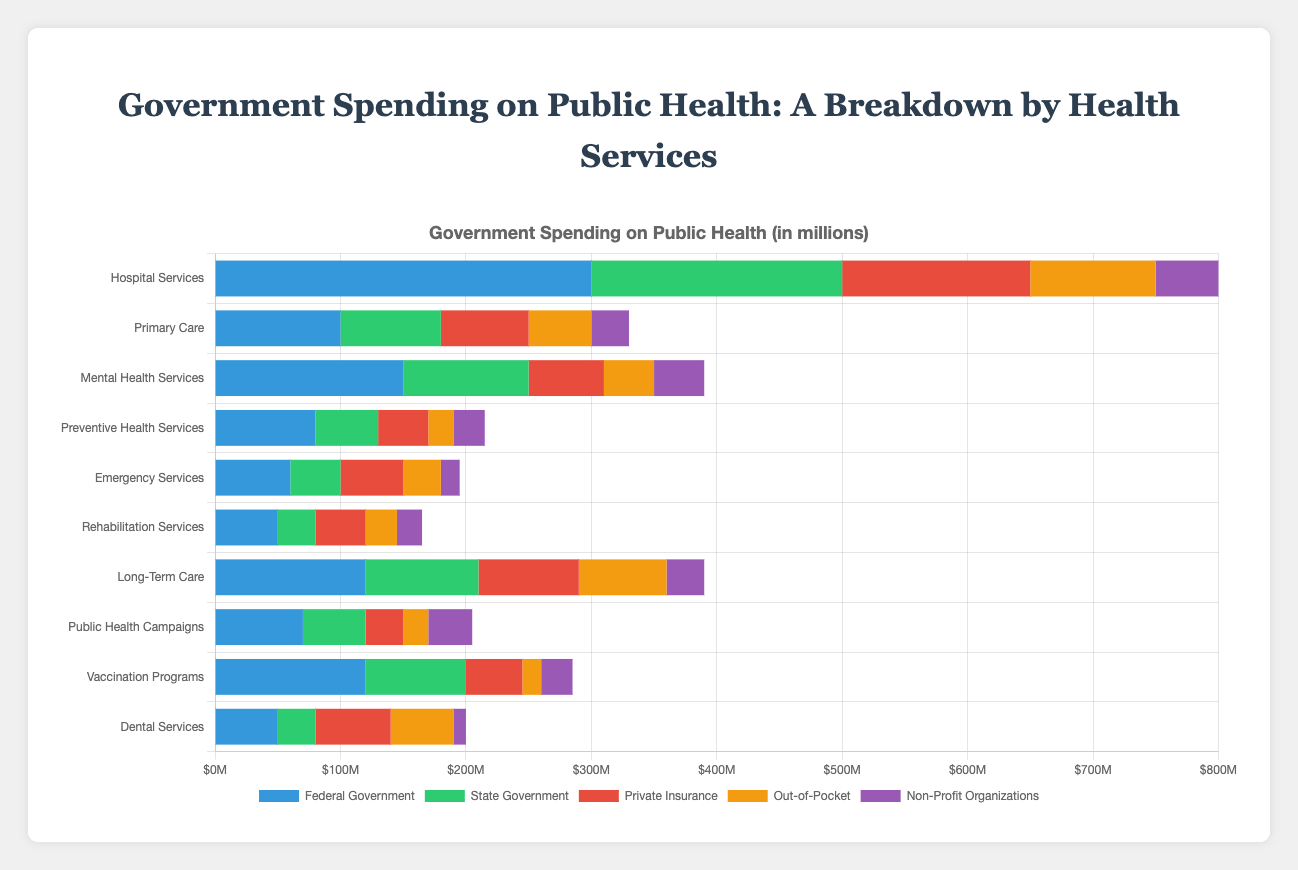Which health service has the highest federal government spending? By examining the horizontal stacked bar chart, the segment for "Federal Government" is the longest for "Hospital Services", indicating the highest federal government spending.
Answer: Hospital Services How much total spending (all sources combined) is there for mental health services? Sum the contributions from all five funding sources for "Mental Health Services": 150,000,000 (Federal) + 100,000,000 (State) + 60,000,000 (Private Insurance) + 40,000,000 (Out-of-Pocket) + 40,000,000 (Non-Profit) = 390,000,000
Answer: 390,000,000 Which funding source contributes the most to vaccination programs? The chart shows the "Federal Government" segment as the longest for "Vaccination Programs", indicating that the federal government is the largest contributor.
Answer: Federal Government What is the difference in state government spending between hospital services and primary care? Subtract the state government spending for "Primary Care" from that for "Hospital Services": 200,000,000 - 80,000,000 = 120,000,000
Answer: 120,000,000 Which health service has the lowest out-of-pocket spending? By checking the horizontal stacked bars for the "Out-of-Pocket" segments, the shortest bar corresponds to "Vaccination Programs" with 15,000,000.
Answer: Vaccination Programs How much more does the federal government spend on long-term care than on emergency services? Subtract the federal government spending for "Emergency Services" from that for "Long-Term Care": 120,000,000 - 60,000,000 = 60,000,000
Answer: 60,000,000 By what percentage does state government spending on preventive health services exceed that on emergency services? Calculate the difference between state spending on "Preventive Health Services" and "Emergency Services", then divide by the spending on "Emergency Services" and multiply by 100: (50,000,000 - 40,000,000) / 40,000,000 * 100 = 25%
Answer: 25% Which two health services have the same amount of out-of-pocket spending? By visually inspecting the "Out-of-Pocket" segments, both "Primary Care" and "Dental Services" have the same out-of-pocket spending of 50,000,000.
Answer: Primary Care, Dental Services For non-profit organizations, which service receives the least funding? By examining the "Non-Profit Organizations" segments, the shortest bar is for "Dental Services" with 10,000,000.
Answer: Dental Services What's the combined total spending from private insurance and non-profit organizations on rehabilitation services? Sum the spending from "Private Insurance" and "Non-Profit Organizations" for "Rehabilitation Services": 40,000,000 + 20,000,000 = 60,000,000
Answer: 60,000,000 